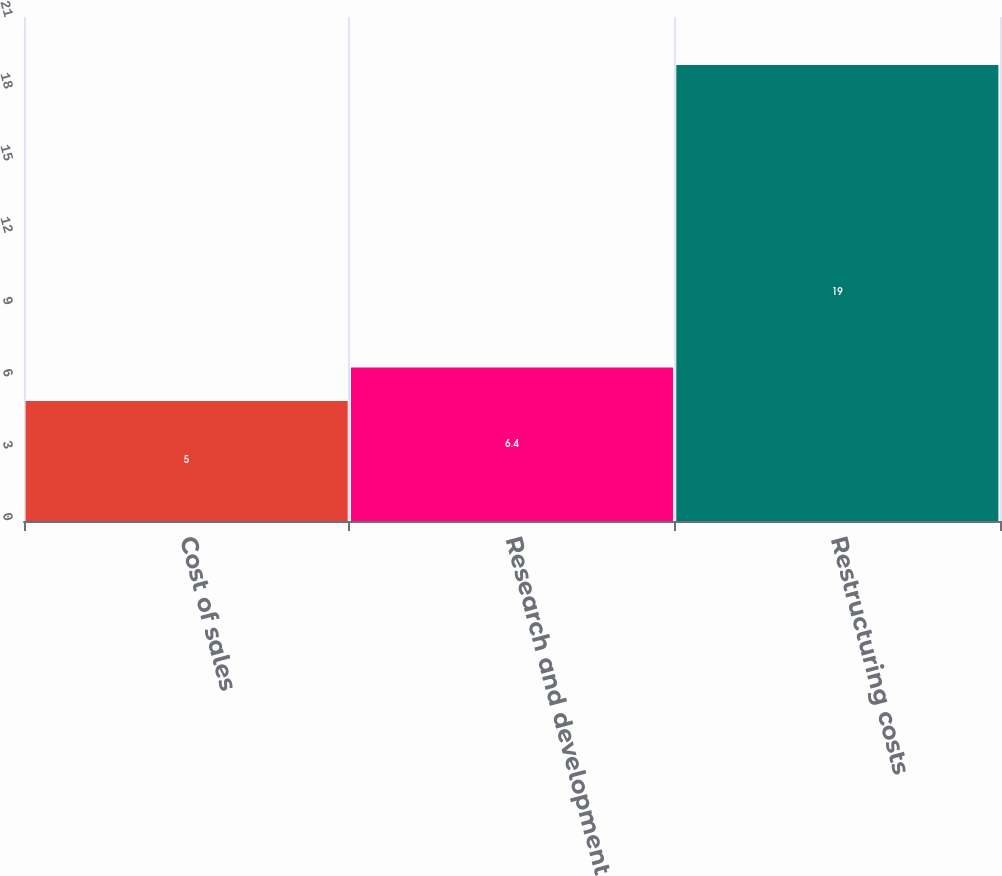Convert chart. <chart><loc_0><loc_0><loc_500><loc_500><bar_chart><fcel>Cost of sales<fcel>Research and development<fcel>Restructuring costs<nl><fcel>5<fcel>6.4<fcel>19<nl></chart> 